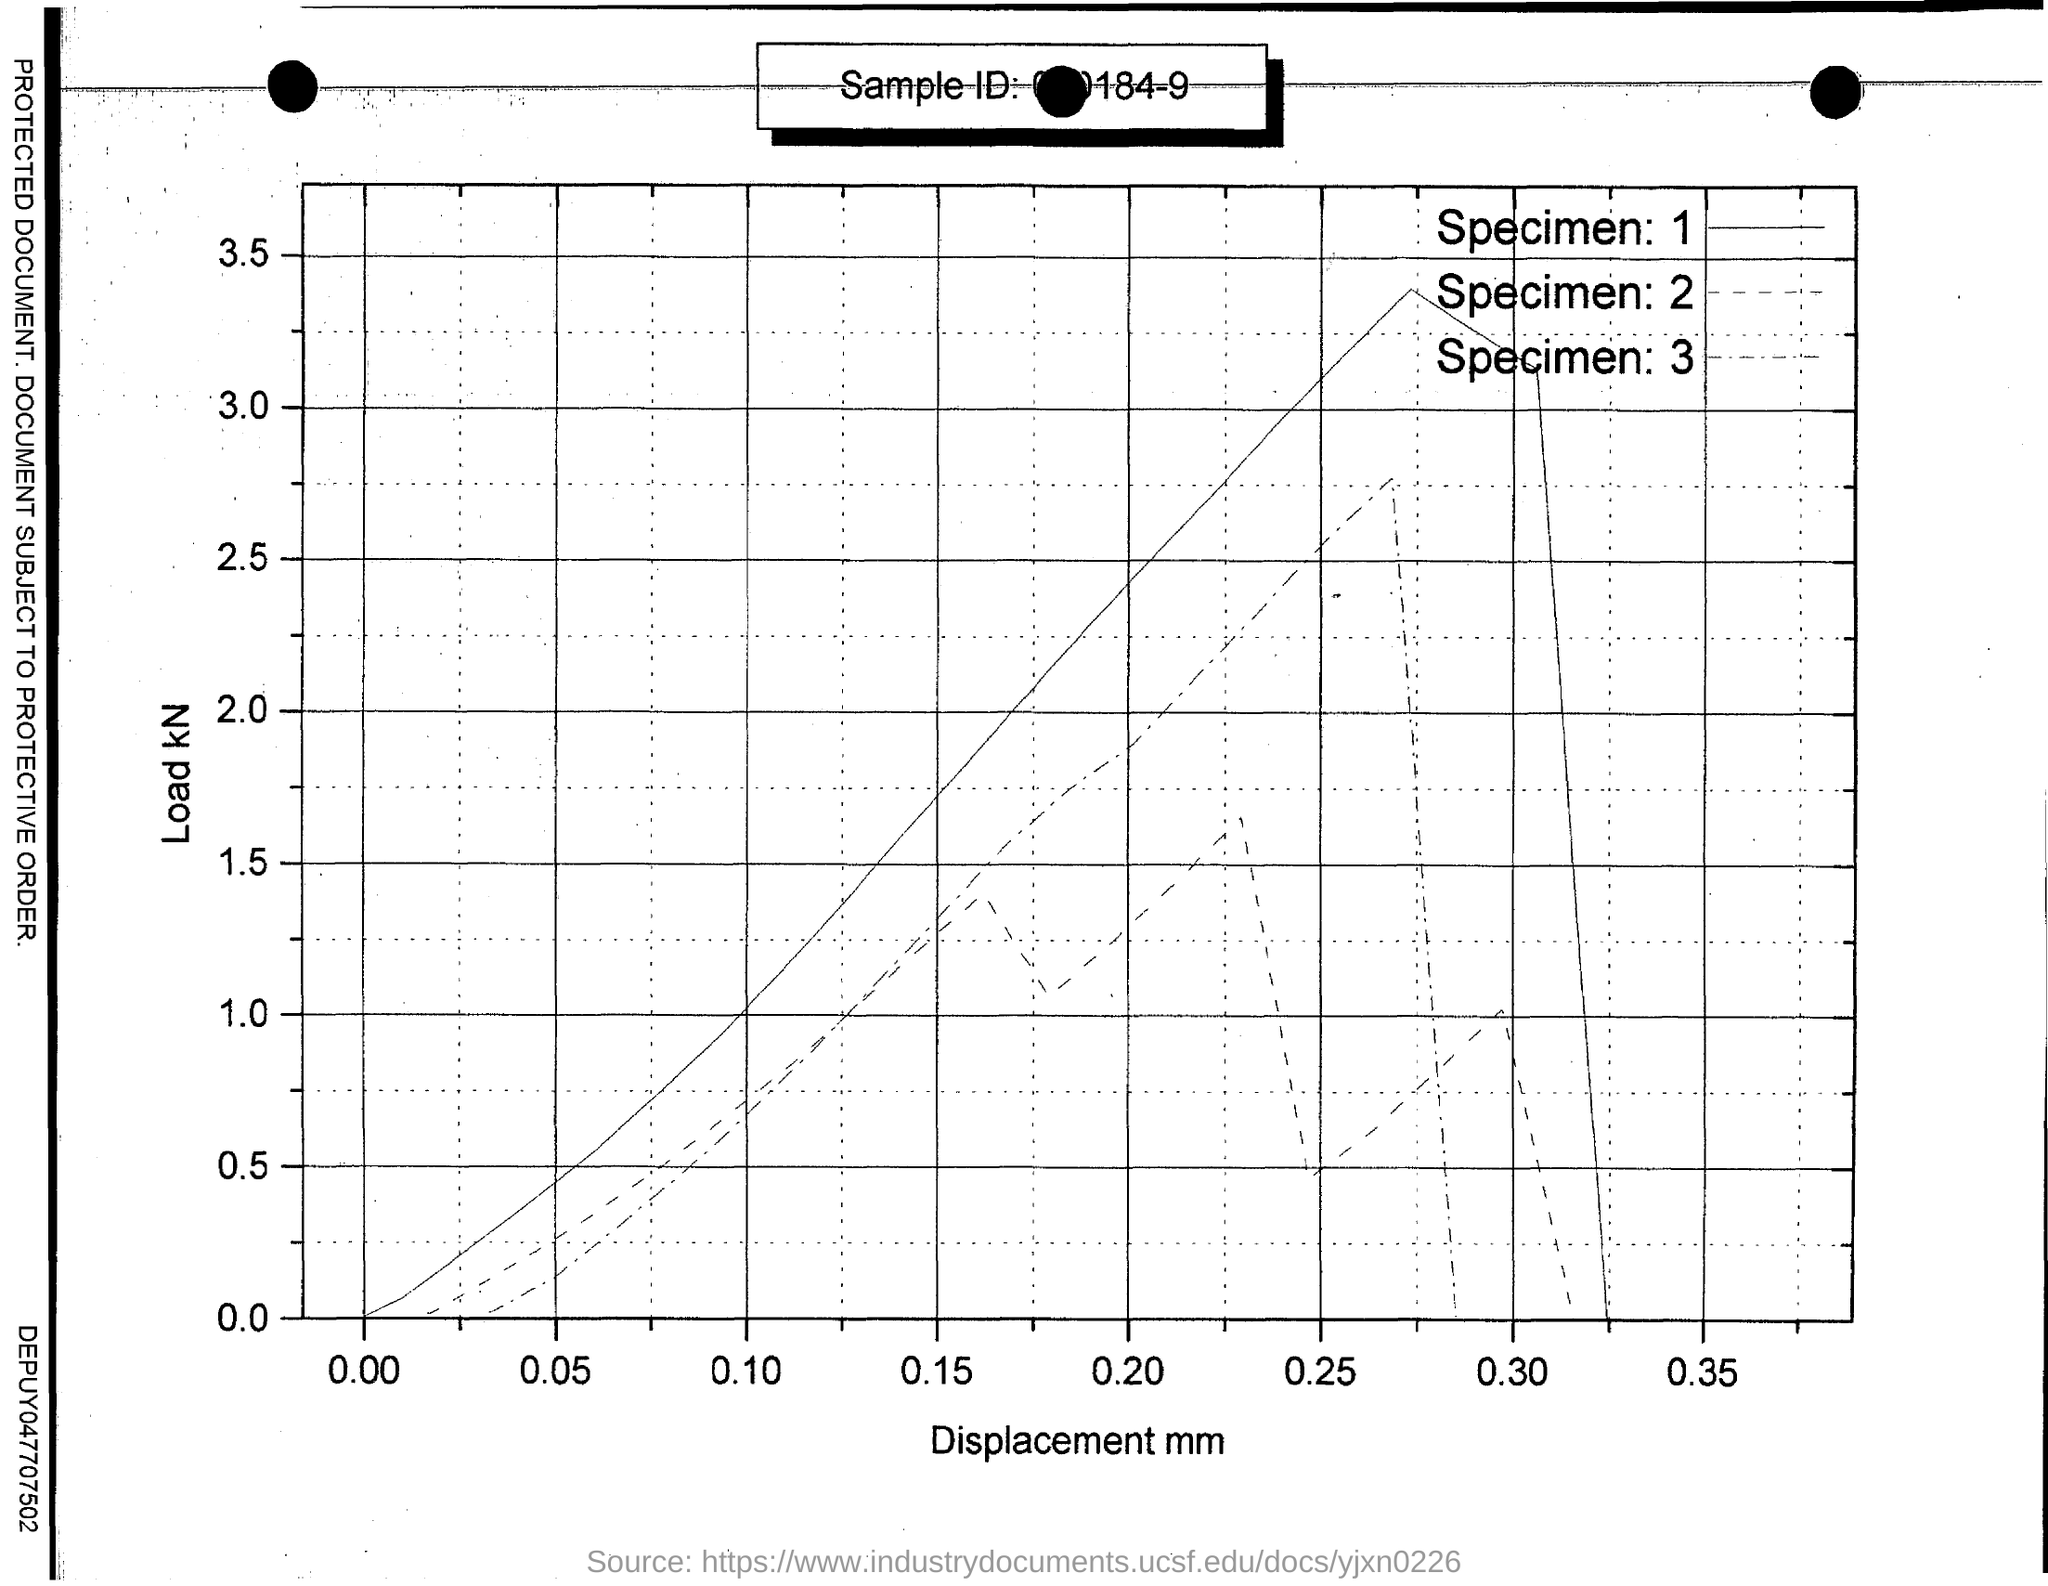What is given on x- axis ?
Your answer should be compact. Displacement mm. What is given on y- axis ?
Offer a terse response. Load kN. 